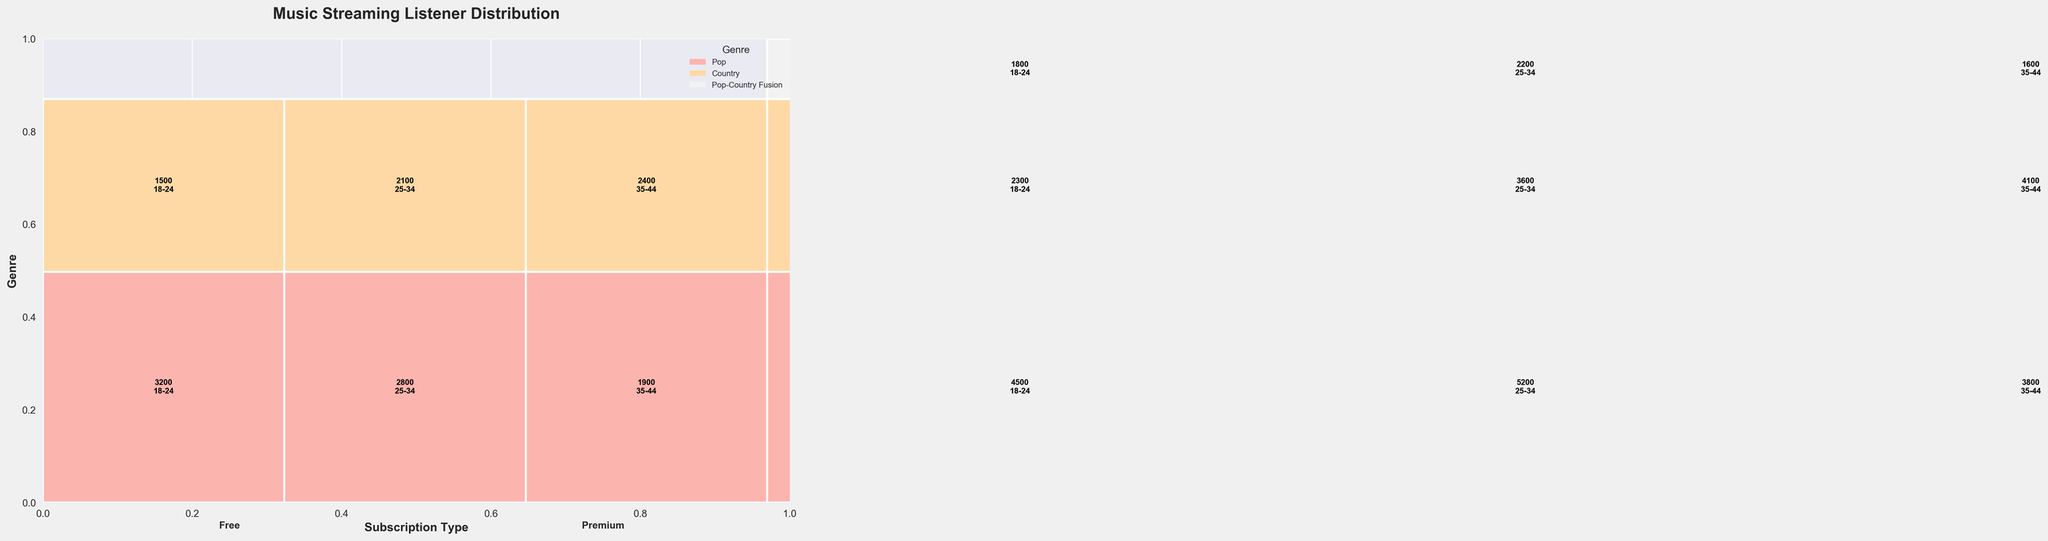Which genre has the highest total number of listeners? The Pop genre's rectangles span the largest vertical height in the plot, indicating it has the highest total number of listeners.
Answer: Pop Which age group has the most listeners for the Pop-Country Fusion genre among Premium subscribers? For Pop-Country Fusion under Premium subscription, the rectangles for the age groups 18-24, 25-34, and 35-44 can be compared. The largest among them is for the age group 25-34.
Answer: 25-34 How many total listeners are there for Country music across all age groups in the Free subscription category? Adding listeners for Country music in Free subscription: 1500 (18-24) + 2100 (25-34) + 2400 (35-44) = 6000.
Answer: 6000 In the Pop genre, which subscription type has a higher number of listeners? Comparing the heights of the rectangles for Pop genre, Premium has taller rectangles than Free, indicating more listeners.
Answer: Premium What is the sum of listeners for the Premium subscription in both 18-24 and 25-34 age groups for Pop music? Adding listeners for Premium subscription in Pop music: 4500 (18-24) + 5200 (25-34) = 9700.
Answer: 9700 Which genre has rectangles with three different colors indicating age groups in both subscription types? Each genre has distinct age group colors, but Pop-Country Fusion is unique since it only appears in the Premium subscription and has three distinct age group colors.
Answer: Pop-Country Fusion What is the average number of listeners for Country music in the 35-44 age group across both subscription types? Adding listeners for 35-44 age group in Country music: 2400 (Free) + 4100 (Premium) = 6500. Average = 6500 / 2 = 3250.
Answer: 3250 Between Pop and Country genres, which has a higher number of listeners in the Premium 25-34 age group? Comparing shapes for Premium 25-34 age group, Pop has 5200 listeners while Country has 3600. Thus, Pop has more listeners.
Answer: Pop Which genre has the smallest combined area (reflecting lowest total number of listeners) in the plot? Observing the plot, Pop-Country Fusion has the smallest area, indicating the fewest listeners overall.
Answer: Pop-Country Fusion 